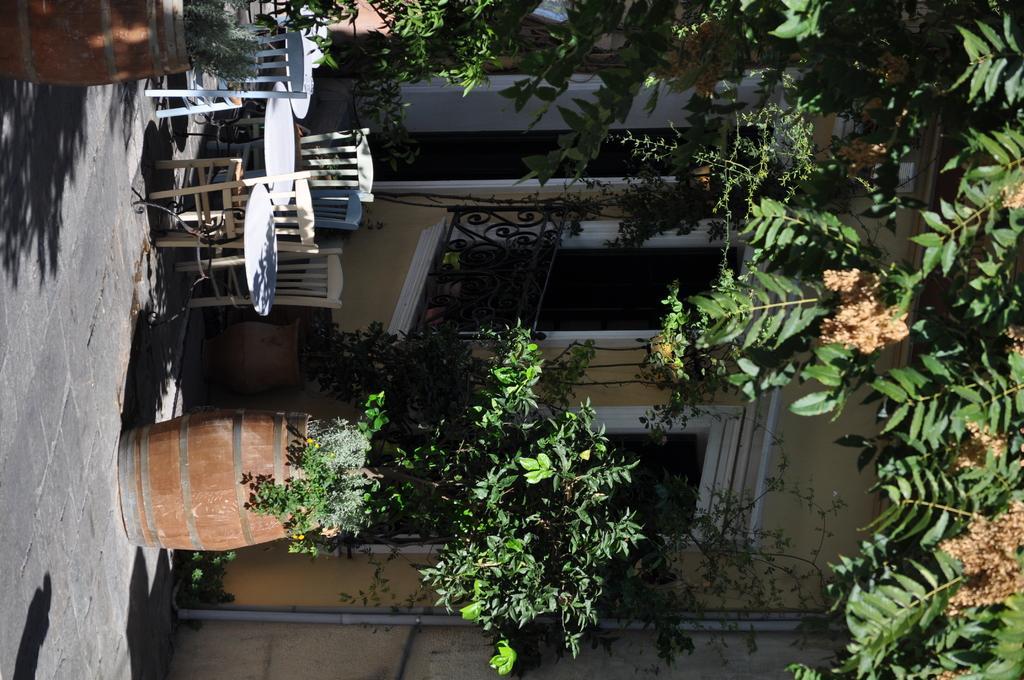Please provide a concise description of this image. This is a tilted image, in this image, on the left side there is a floor, table, chairs and flower pots, in the background there is a house and trees. 